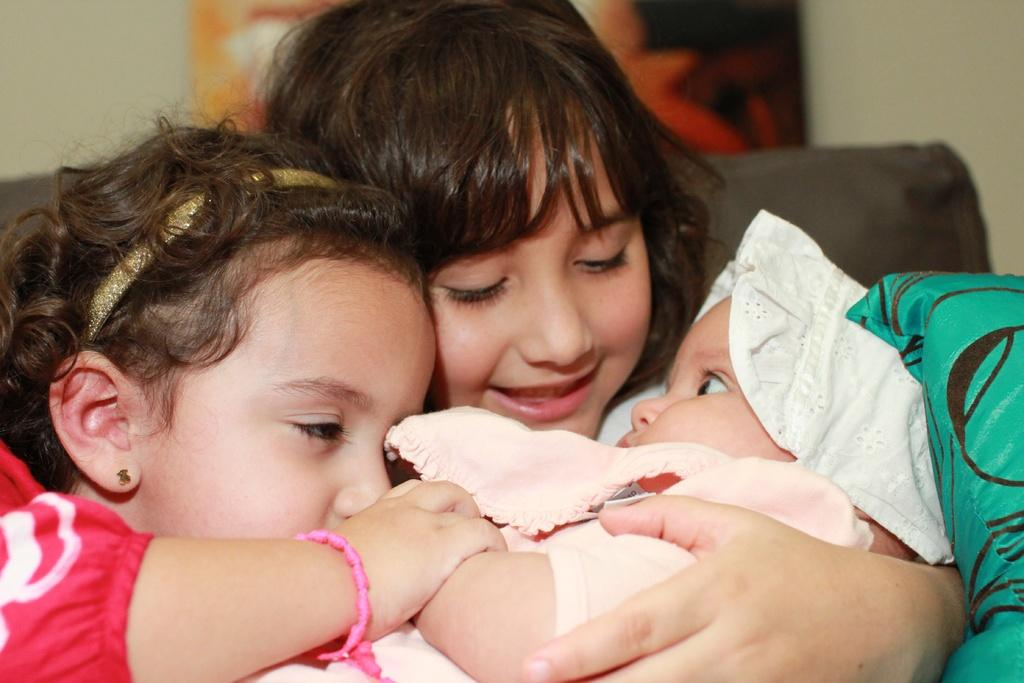How many children are present in the image? There are 2 children in the image. What are the children doing in the image? The children are holding a baby. Can you describe the background of the image? The background of the image is blurred. Where is the throne located in the image? There is no throne present in the image. Is there a lock on the baby's crib in the image? There is no crib or lock present in the image. 